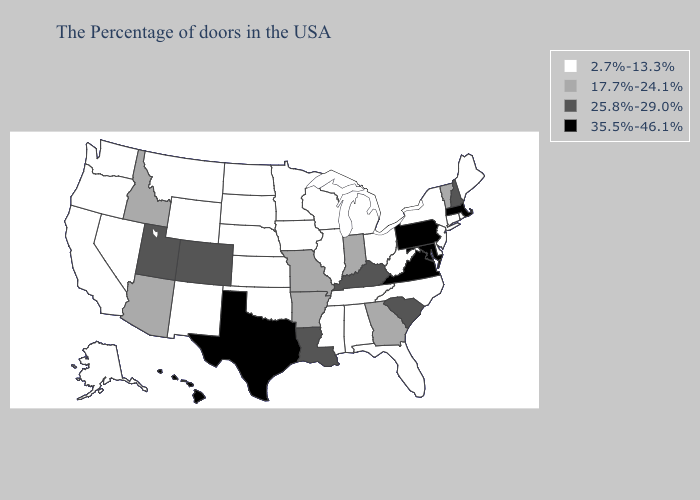Among the states that border California , which have the lowest value?
Concise answer only. Nevada, Oregon. Name the states that have a value in the range 35.5%-46.1%?
Quick response, please. Massachusetts, Maryland, Pennsylvania, Virginia, Texas, Hawaii. Name the states that have a value in the range 35.5%-46.1%?
Quick response, please. Massachusetts, Maryland, Pennsylvania, Virginia, Texas, Hawaii. What is the highest value in the USA?
Short answer required. 35.5%-46.1%. Name the states that have a value in the range 35.5%-46.1%?
Answer briefly. Massachusetts, Maryland, Pennsylvania, Virginia, Texas, Hawaii. Does Oklahoma have the highest value in the USA?
Be succinct. No. What is the value of Georgia?
Write a very short answer. 17.7%-24.1%. Name the states that have a value in the range 2.7%-13.3%?
Give a very brief answer. Maine, Rhode Island, Connecticut, New York, New Jersey, Delaware, North Carolina, West Virginia, Ohio, Florida, Michigan, Alabama, Tennessee, Wisconsin, Illinois, Mississippi, Minnesota, Iowa, Kansas, Nebraska, Oklahoma, South Dakota, North Dakota, Wyoming, New Mexico, Montana, Nevada, California, Washington, Oregon, Alaska. What is the value of Arizona?
Answer briefly. 17.7%-24.1%. Name the states that have a value in the range 17.7%-24.1%?
Concise answer only. Vermont, Georgia, Indiana, Missouri, Arkansas, Arizona, Idaho. Which states have the lowest value in the USA?
Answer briefly. Maine, Rhode Island, Connecticut, New York, New Jersey, Delaware, North Carolina, West Virginia, Ohio, Florida, Michigan, Alabama, Tennessee, Wisconsin, Illinois, Mississippi, Minnesota, Iowa, Kansas, Nebraska, Oklahoma, South Dakota, North Dakota, Wyoming, New Mexico, Montana, Nevada, California, Washington, Oregon, Alaska. What is the value of Texas?
Be succinct. 35.5%-46.1%. Does Idaho have the same value as Pennsylvania?
Quick response, please. No. Does Georgia have a higher value than New Jersey?
Quick response, please. Yes. 